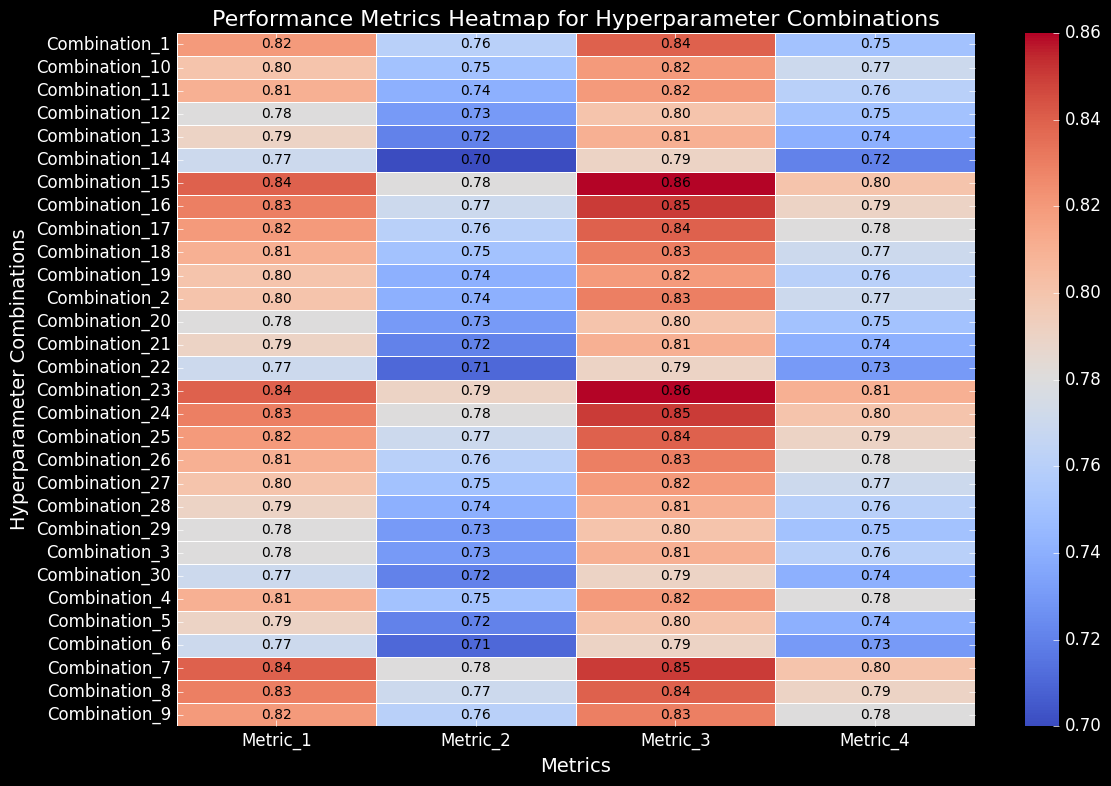Which hyperparameter combination has the highest score for Metric_3? Look at the column for Metric_3 and identify the highest value. The highest value is 0.86, which corresponds to Combination_15 and Combination_23.
Answer: Combination_15 and Combination_23 Which combination has the lowest score for Metric_4? Look at the column for Metric_4 and identify the lowest value. The lowest value is 0.72, which corresponds to Combination_14.
Answer: Combination_14 What is the average score of Metric_2 across all combinations? Sum all the values in the Metric_2 column and divide by the number of combinations (30). (0.76 + 0.74 + 0.73 + 0.75 + 0.72 + 0.71 + 0.78 + 0.77 + 0.76 + 0.75 + 0.74 + 0.73 + 0.72 + 0.70 + 0.78 + 0.77 + 0.76 + 0.75 + 0.74 + 0.73 + 0.72 + 0.71 + 0.79 + 0.78 + 0.77 + 0.76 + 0.75 + 0.74 + 0.73 + 0.72) / 30 = 22.32 / 30 ≈ 0.744
Answer: 0.74 Which metric has the highest average score across all combinations? Calculate the average score for each metric by summing the column values and dividing by the number of combinations (30). Metric_1: (0.82+0.80+...+0.77)/30 = 0.80, Metric_2: 0.744, Metric_3: 0.83, Metric_4: 0.76. Metric_3 has the highest average score.
Answer: Metric_3 Is there a hyperparameter combination that has consistently higher scores across all metrics? Look for a combination where all scores are relatively high. Combination_15 and Combination_23 have high scores across all metrics: (0.84, 0.78, 0.86, 0.80) and (0.84, 0.79, 0.86, 0.81).
Answer: Combination_15 and Combination_23 Which combination shows the greatest variation in scores across different metrics? Calculate the range (max - min) of scores for each combination and identify the largest. Combination_14 has the greatest variation with (0.77, 0.70, 0.79, 0.72), range = 0.79 - 0.70 = 0.09.
Answer: Combination_14 Between Combination_7 and Combination_8, which one has a higher score for Metric_2? Compare the values under Metric_2 for Combination_7 (0.78) and Combination_8 (0.77).
Answer: Combination_7 What is the difference in Metric_4 scores between Combination_23 and Combination_24? Subtract the Metric_4 value of Combination_24 (0.80) from Combination_23 (0.81). 0.81 - 0.80 = 0.01
Answer: 0.01 Which combination has the most balanced performance across all metrics? Look for combinations with small variations between their scores. Combination_25 has (0.82, 0.77, 0.84, 0.79) with a small range: 0.84 - 0.77 = 0.07.
Answer: Combination_25 